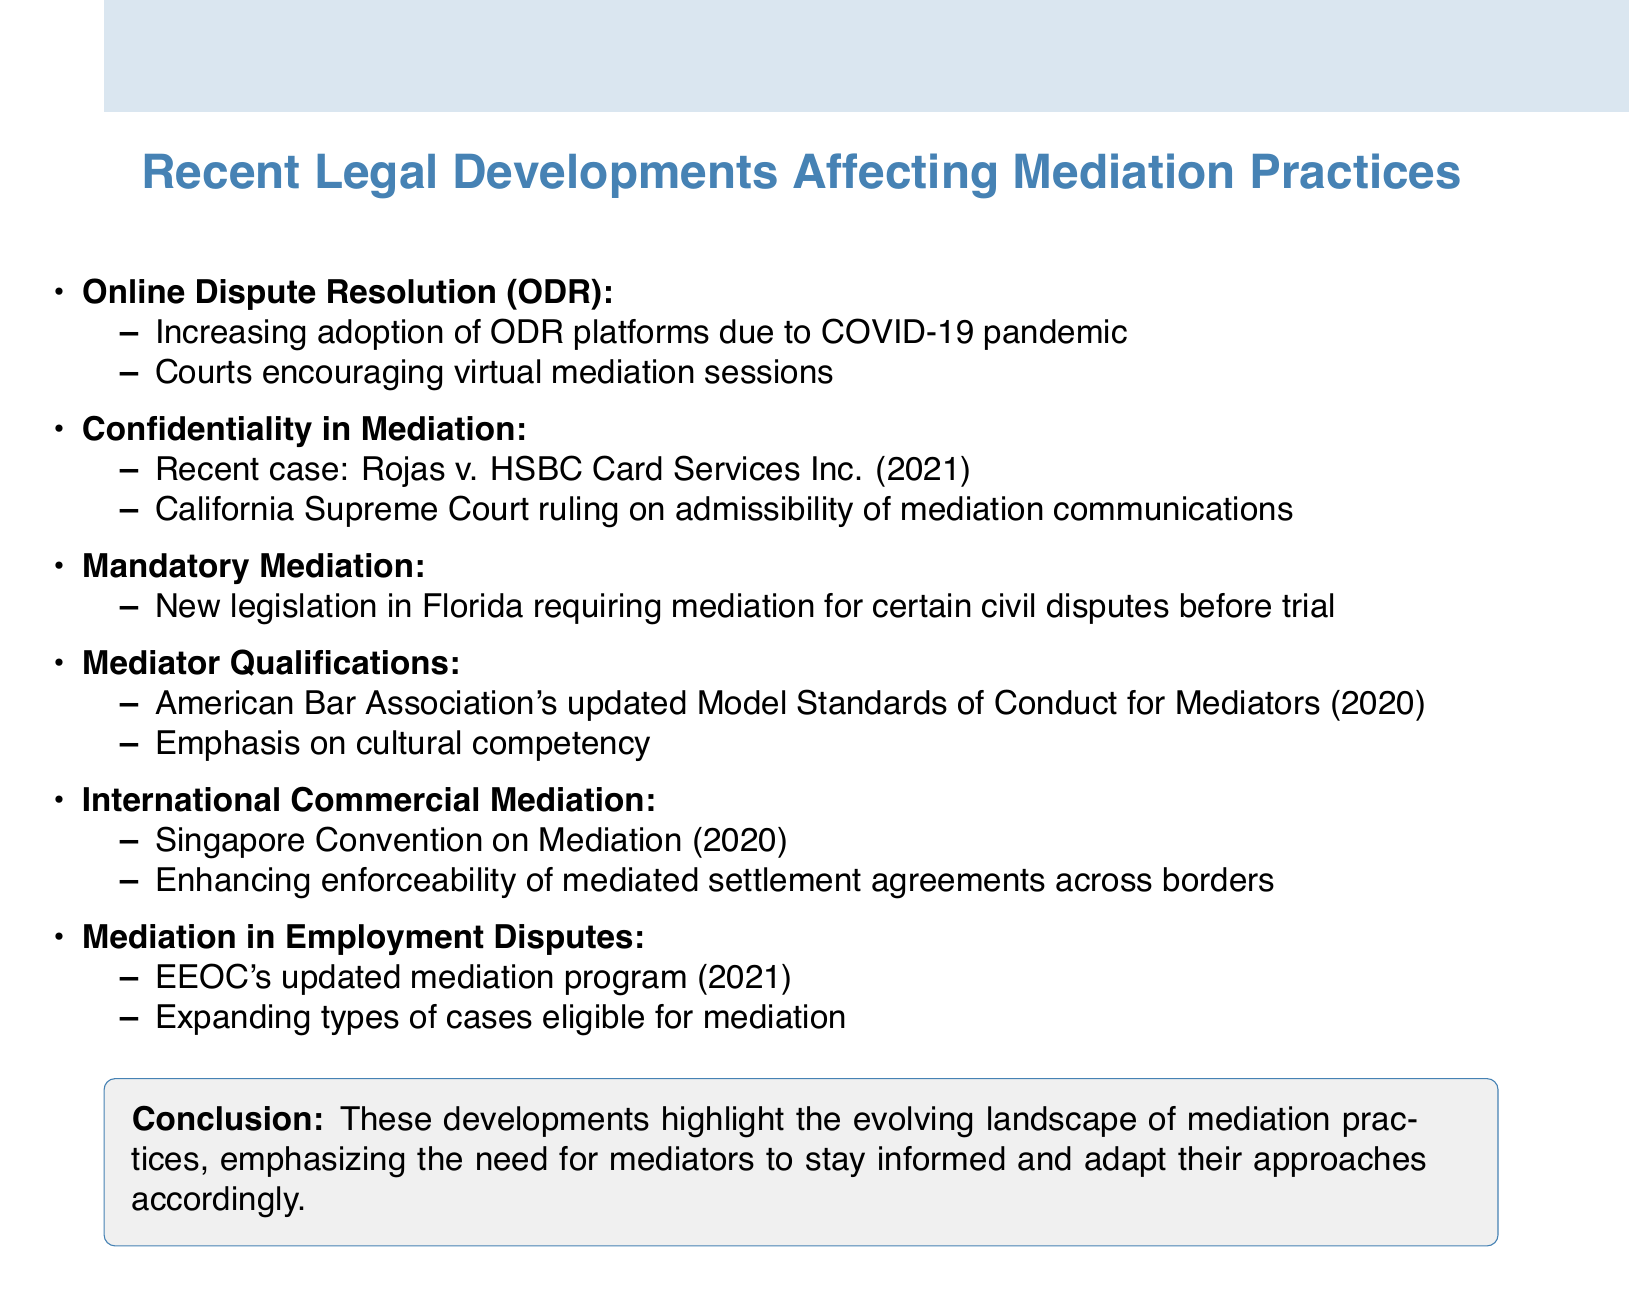What recent event increased the adoption of ODR platforms? The COVID-19 pandemic led to an increasing adoption of ODR platforms.
Answer: COVID-19 pandemic What case is mentioned regarding confidentiality in mediation? The case referenced in relation to confidentiality is Rojas v. HSBC Card Services Inc. (2021).
Answer: Rojas v. HSBC Card Services Inc. (2021) What new requirement has been established in Florida concerning mediation? Florida now requires mediation for certain civil disputes before trial.
Answer: Mediation before trial Which organization's standards emphasize cultural competency for mediators? The American Bar Association's updated Model Standards emphasize cultural competency.
Answer: American Bar Association What international agreement is mentioned that enhances enforceability of mediated settlements? The Singapore Convention on Mediation (2020) is mentioned for enhancing enforceability.
Answer: Singapore Convention on Mediation What type of disputes does the EEOC's updated mediation program now expand to include? The updated mediation program expands the types of cases eligible for mediation.
Answer: Employment disputes 